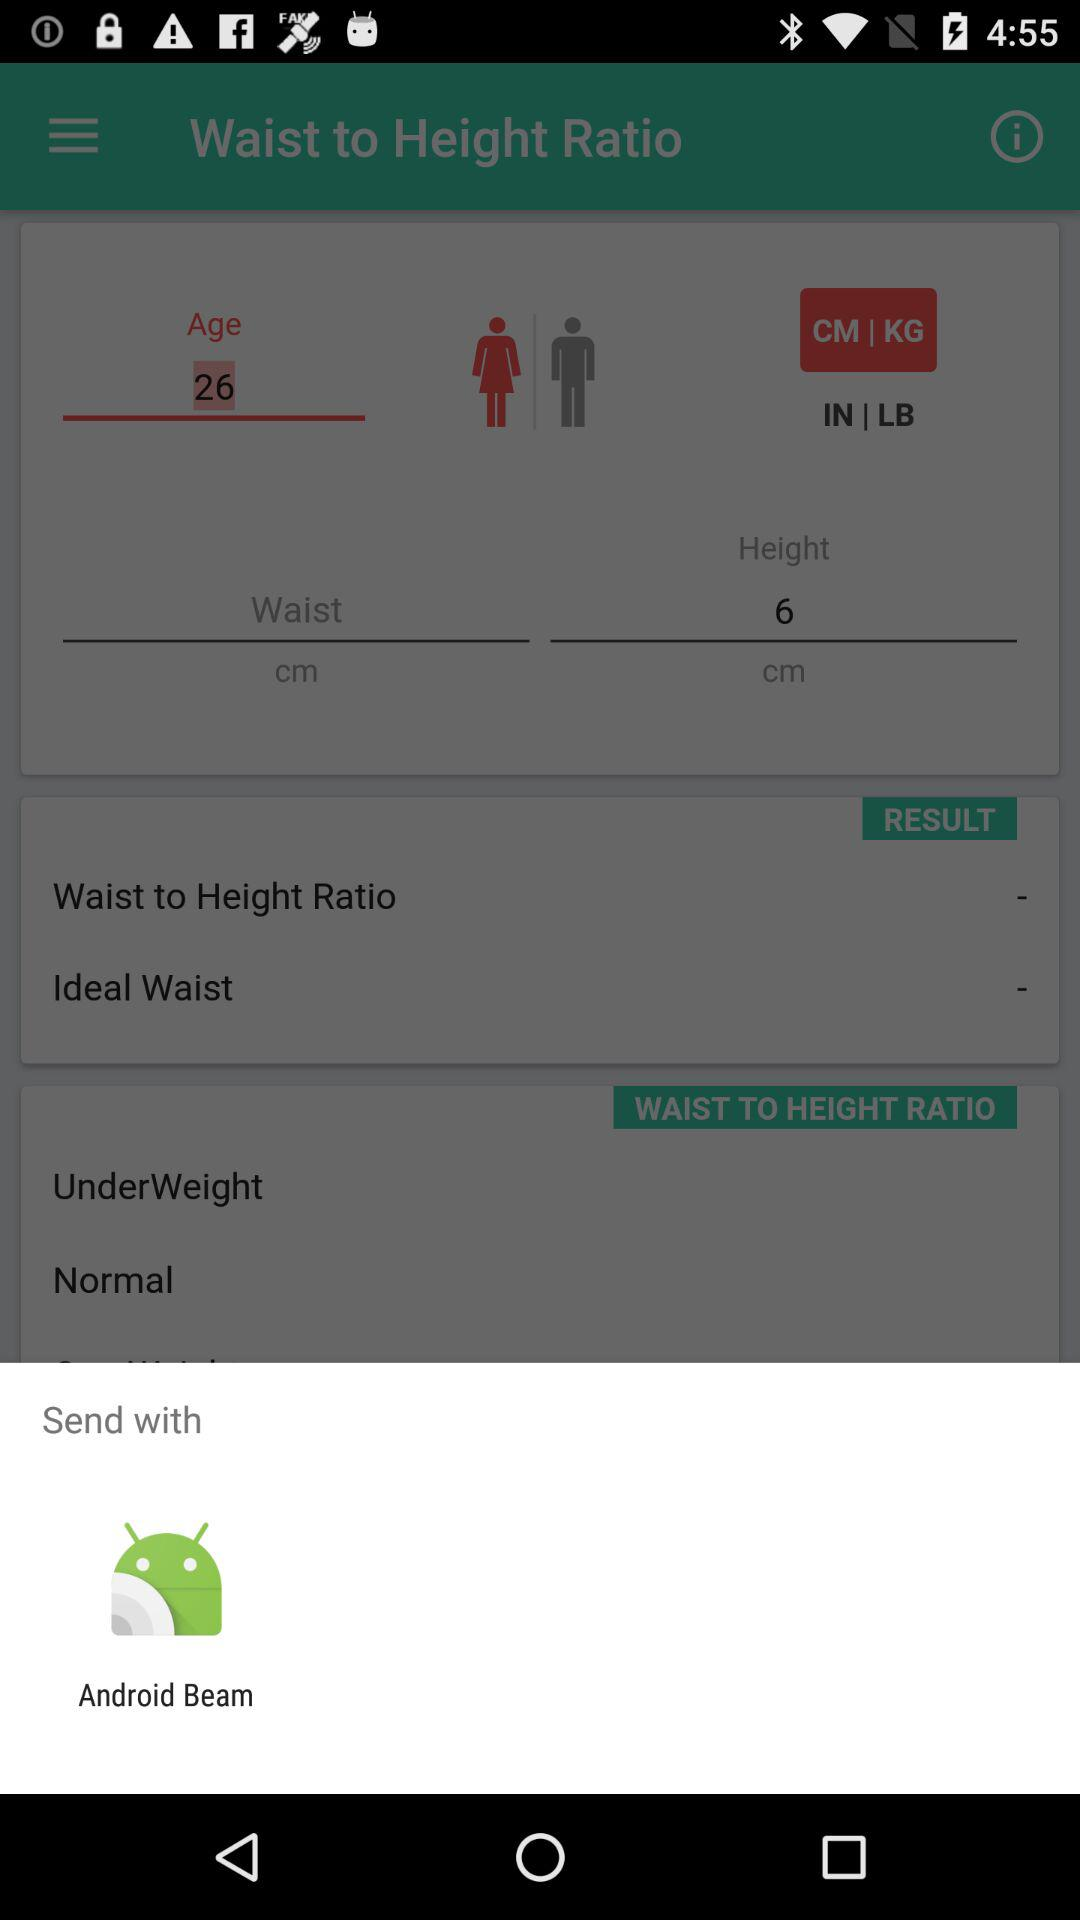Through what application can we send? You can send through "Android Beam". 